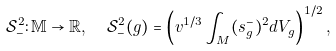<formula> <loc_0><loc_0><loc_500><loc_500>\mathcal { S } _ { - } ^ { 2 } \colon { \mathbb { M } } \rightarrow { \mathbb { R } } , \ \ { \mathcal { S } } _ { - } ^ { 2 } ( g ) = \left ( v ^ { 1 / 3 } \int _ { M } ( s _ { g } ^ { - } ) ^ { 2 } d V _ { g } \right ) ^ { 1 / 2 } ,</formula> 